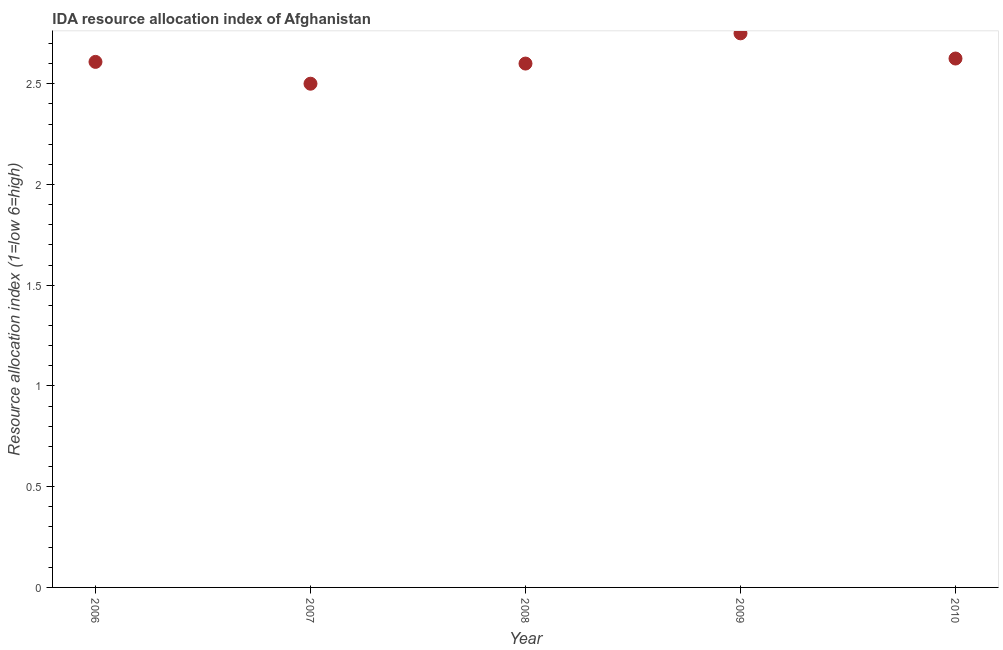What is the ida resource allocation index in 2010?
Give a very brief answer. 2.62. Across all years, what is the maximum ida resource allocation index?
Keep it short and to the point. 2.75. Across all years, what is the minimum ida resource allocation index?
Your response must be concise. 2.5. In which year was the ida resource allocation index maximum?
Make the answer very short. 2009. What is the sum of the ida resource allocation index?
Offer a very short reply. 13.08. What is the difference between the ida resource allocation index in 2009 and 2010?
Your answer should be compact. 0.12. What is the average ida resource allocation index per year?
Offer a very short reply. 2.62. What is the median ida resource allocation index?
Your answer should be very brief. 2.61. In how many years, is the ida resource allocation index greater than 1.6 ?
Offer a very short reply. 5. Do a majority of the years between 2009 and 2008 (inclusive) have ida resource allocation index greater than 0.9 ?
Keep it short and to the point. No. What is the ratio of the ida resource allocation index in 2006 to that in 2010?
Make the answer very short. 0.99. Is the ida resource allocation index in 2008 less than that in 2009?
Make the answer very short. Yes. Is the difference between the ida resource allocation index in 2006 and 2008 greater than the difference between any two years?
Give a very brief answer. No. Is the sum of the ida resource allocation index in 2007 and 2008 greater than the maximum ida resource allocation index across all years?
Ensure brevity in your answer.  Yes. What is the difference between the highest and the lowest ida resource allocation index?
Give a very brief answer. 0.25. In how many years, is the ida resource allocation index greater than the average ida resource allocation index taken over all years?
Your response must be concise. 2. Does the ida resource allocation index monotonically increase over the years?
Offer a very short reply. No. How many dotlines are there?
Offer a terse response. 1. What is the difference between two consecutive major ticks on the Y-axis?
Give a very brief answer. 0.5. Are the values on the major ticks of Y-axis written in scientific E-notation?
Your answer should be very brief. No. Does the graph contain any zero values?
Keep it short and to the point. No. Does the graph contain grids?
Your answer should be very brief. No. What is the title of the graph?
Your response must be concise. IDA resource allocation index of Afghanistan. What is the label or title of the X-axis?
Your answer should be very brief. Year. What is the label or title of the Y-axis?
Provide a succinct answer. Resource allocation index (1=low 6=high). What is the Resource allocation index (1=low 6=high) in 2006?
Your response must be concise. 2.61. What is the Resource allocation index (1=low 6=high) in 2007?
Offer a terse response. 2.5. What is the Resource allocation index (1=low 6=high) in 2008?
Provide a short and direct response. 2.6. What is the Resource allocation index (1=low 6=high) in 2009?
Ensure brevity in your answer.  2.75. What is the Resource allocation index (1=low 6=high) in 2010?
Ensure brevity in your answer.  2.62. What is the difference between the Resource allocation index (1=low 6=high) in 2006 and 2007?
Provide a short and direct response. 0.11. What is the difference between the Resource allocation index (1=low 6=high) in 2006 and 2008?
Offer a terse response. 0.01. What is the difference between the Resource allocation index (1=low 6=high) in 2006 and 2009?
Your response must be concise. -0.14. What is the difference between the Resource allocation index (1=low 6=high) in 2006 and 2010?
Provide a succinct answer. -0.02. What is the difference between the Resource allocation index (1=low 6=high) in 2007 and 2009?
Offer a very short reply. -0.25. What is the difference between the Resource allocation index (1=low 6=high) in 2007 and 2010?
Provide a short and direct response. -0.12. What is the difference between the Resource allocation index (1=low 6=high) in 2008 and 2009?
Make the answer very short. -0.15. What is the difference between the Resource allocation index (1=low 6=high) in 2008 and 2010?
Offer a terse response. -0.03. What is the ratio of the Resource allocation index (1=low 6=high) in 2006 to that in 2007?
Your answer should be very brief. 1.04. What is the ratio of the Resource allocation index (1=low 6=high) in 2006 to that in 2009?
Provide a succinct answer. 0.95. What is the ratio of the Resource allocation index (1=low 6=high) in 2006 to that in 2010?
Keep it short and to the point. 0.99. What is the ratio of the Resource allocation index (1=low 6=high) in 2007 to that in 2009?
Make the answer very short. 0.91. What is the ratio of the Resource allocation index (1=low 6=high) in 2008 to that in 2009?
Offer a terse response. 0.94. What is the ratio of the Resource allocation index (1=low 6=high) in 2008 to that in 2010?
Provide a short and direct response. 0.99. What is the ratio of the Resource allocation index (1=low 6=high) in 2009 to that in 2010?
Provide a succinct answer. 1.05. 